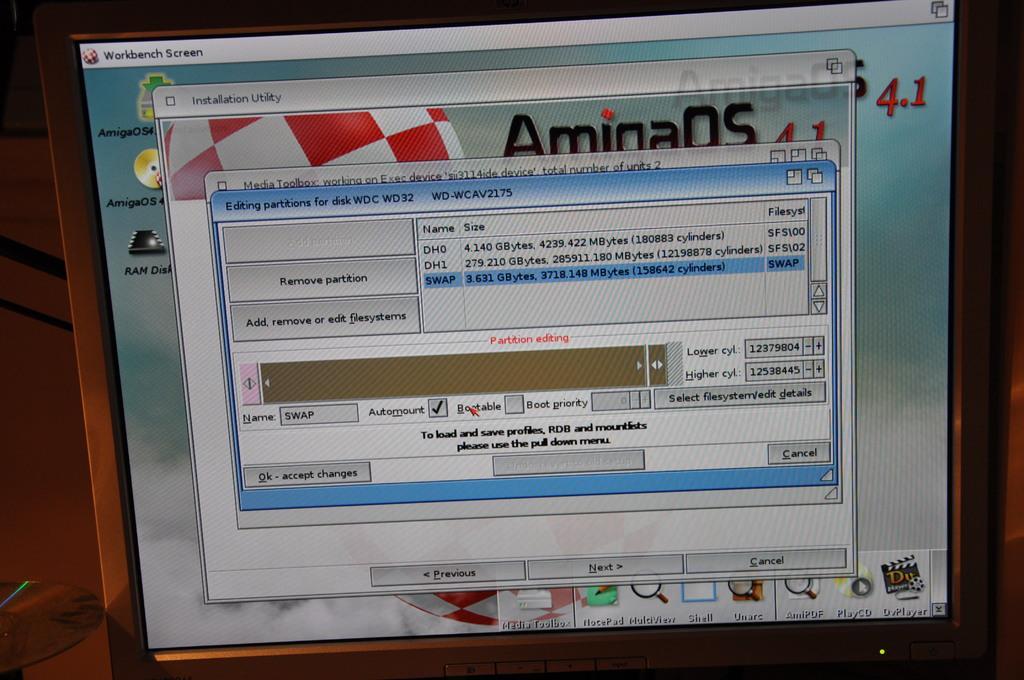Describe this image in one or two sentences. In this image there is a monitor. There are four tabs opened on the screen. On the bottom of monitor there are some icons. And left side also there are some more icons seen. There is a brown color background. 